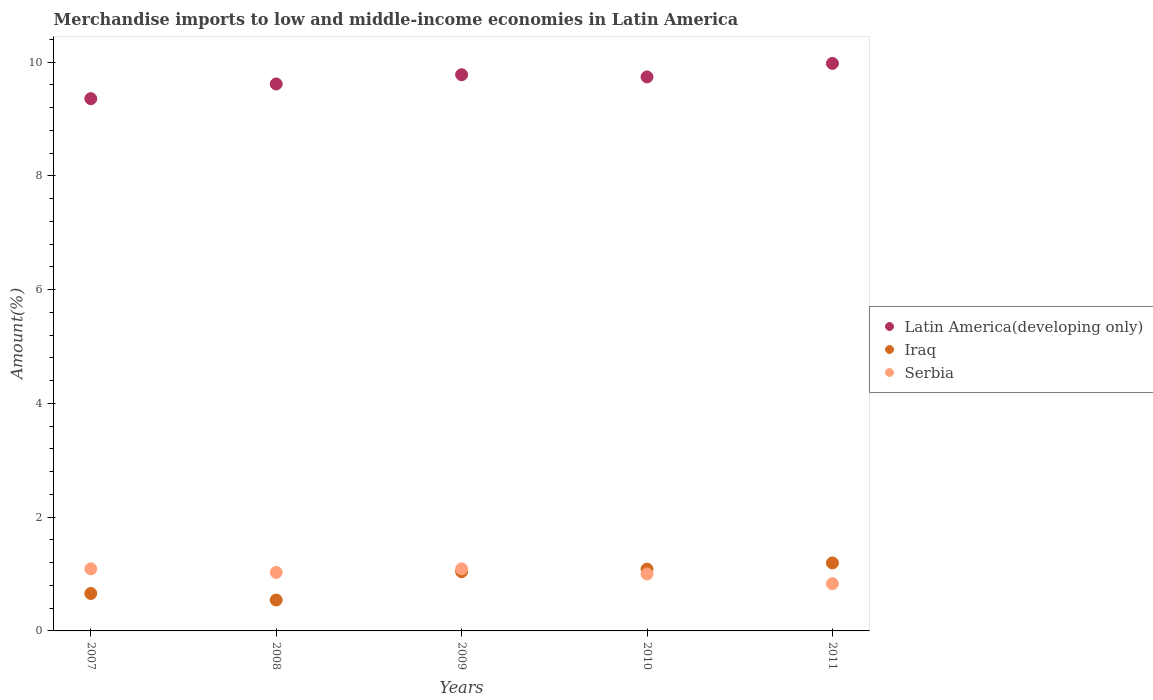How many different coloured dotlines are there?
Provide a succinct answer. 3. Is the number of dotlines equal to the number of legend labels?
Provide a short and direct response. Yes. What is the percentage of amount earned from merchandise imports in Iraq in 2011?
Provide a short and direct response. 1.2. Across all years, what is the maximum percentage of amount earned from merchandise imports in Serbia?
Keep it short and to the point. 1.09. Across all years, what is the minimum percentage of amount earned from merchandise imports in Serbia?
Offer a very short reply. 0.83. What is the total percentage of amount earned from merchandise imports in Iraq in the graph?
Keep it short and to the point. 4.52. What is the difference between the percentage of amount earned from merchandise imports in Serbia in 2007 and that in 2011?
Your answer should be compact. 0.26. What is the difference between the percentage of amount earned from merchandise imports in Latin America(developing only) in 2007 and the percentage of amount earned from merchandise imports in Iraq in 2008?
Give a very brief answer. 8.81. What is the average percentage of amount earned from merchandise imports in Serbia per year?
Keep it short and to the point. 1.01. In the year 2009, what is the difference between the percentage of amount earned from merchandise imports in Latin America(developing only) and percentage of amount earned from merchandise imports in Iraq?
Offer a very short reply. 8.74. What is the ratio of the percentage of amount earned from merchandise imports in Latin America(developing only) in 2008 to that in 2011?
Your response must be concise. 0.96. What is the difference between the highest and the second highest percentage of amount earned from merchandise imports in Latin America(developing only)?
Provide a succinct answer. 0.2. What is the difference between the highest and the lowest percentage of amount earned from merchandise imports in Latin America(developing only)?
Offer a terse response. 0.62. Is the sum of the percentage of amount earned from merchandise imports in Serbia in 2008 and 2009 greater than the maximum percentage of amount earned from merchandise imports in Iraq across all years?
Your answer should be compact. Yes. Does the percentage of amount earned from merchandise imports in Latin America(developing only) monotonically increase over the years?
Make the answer very short. No. Is the percentage of amount earned from merchandise imports in Latin America(developing only) strictly less than the percentage of amount earned from merchandise imports in Serbia over the years?
Your response must be concise. No. Does the graph contain any zero values?
Give a very brief answer. No. How many legend labels are there?
Your answer should be compact. 3. What is the title of the graph?
Your answer should be very brief. Merchandise imports to low and middle-income economies in Latin America. What is the label or title of the X-axis?
Your response must be concise. Years. What is the label or title of the Y-axis?
Your answer should be compact. Amount(%). What is the Amount(%) in Latin America(developing only) in 2007?
Keep it short and to the point. 9.36. What is the Amount(%) of Iraq in 2007?
Provide a short and direct response. 0.66. What is the Amount(%) in Serbia in 2007?
Offer a terse response. 1.09. What is the Amount(%) in Latin America(developing only) in 2008?
Your response must be concise. 9.61. What is the Amount(%) of Iraq in 2008?
Provide a succinct answer. 0.54. What is the Amount(%) in Serbia in 2008?
Provide a short and direct response. 1.03. What is the Amount(%) of Latin America(developing only) in 2009?
Give a very brief answer. 9.78. What is the Amount(%) of Iraq in 2009?
Your answer should be very brief. 1.04. What is the Amount(%) in Serbia in 2009?
Make the answer very short. 1.09. What is the Amount(%) of Latin America(developing only) in 2010?
Provide a short and direct response. 9.74. What is the Amount(%) in Iraq in 2010?
Make the answer very short. 1.09. What is the Amount(%) in Serbia in 2010?
Your answer should be very brief. 1. What is the Amount(%) in Latin America(developing only) in 2011?
Provide a succinct answer. 9.98. What is the Amount(%) in Iraq in 2011?
Your answer should be compact. 1.2. What is the Amount(%) in Serbia in 2011?
Your response must be concise. 0.83. Across all years, what is the maximum Amount(%) of Latin America(developing only)?
Your answer should be very brief. 9.98. Across all years, what is the maximum Amount(%) in Iraq?
Provide a short and direct response. 1.2. Across all years, what is the maximum Amount(%) of Serbia?
Provide a succinct answer. 1.09. Across all years, what is the minimum Amount(%) of Latin America(developing only)?
Offer a very short reply. 9.36. Across all years, what is the minimum Amount(%) in Iraq?
Make the answer very short. 0.54. Across all years, what is the minimum Amount(%) in Serbia?
Provide a succinct answer. 0.83. What is the total Amount(%) in Latin America(developing only) in the graph?
Provide a succinct answer. 48.46. What is the total Amount(%) in Iraq in the graph?
Provide a succinct answer. 4.52. What is the total Amount(%) in Serbia in the graph?
Offer a terse response. 5.04. What is the difference between the Amount(%) in Latin America(developing only) in 2007 and that in 2008?
Make the answer very short. -0.26. What is the difference between the Amount(%) in Iraq in 2007 and that in 2008?
Provide a succinct answer. 0.11. What is the difference between the Amount(%) in Serbia in 2007 and that in 2008?
Make the answer very short. 0.06. What is the difference between the Amount(%) in Latin America(developing only) in 2007 and that in 2009?
Offer a terse response. -0.42. What is the difference between the Amount(%) of Iraq in 2007 and that in 2009?
Your response must be concise. -0.38. What is the difference between the Amount(%) of Serbia in 2007 and that in 2009?
Offer a very short reply. -0. What is the difference between the Amount(%) of Latin America(developing only) in 2007 and that in 2010?
Make the answer very short. -0.38. What is the difference between the Amount(%) in Iraq in 2007 and that in 2010?
Provide a short and direct response. -0.43. What is the difference between the Amount(%) of Serbia in 2007 and that in 2010?
Make the answer very short. 0.09. What is the difference between the Amount(%) in Latin America(developing only) in 2007 and that in 2011?
Keep it short and to the point. -0.62. What is the difference between the Amount(%) of Iraq in 2007 and that in 2011?
Your answer should be compact. -0.54. What is the difference between the Amount(%) in Serbia in 2007 and that in 2011?
Your answer should be very brief. 0.26. What is the difference between the Amount(%) in Latin America(developing only) in 2008 and that in 2009?
Give a very brief answer. -0.16. What is the difference between the Amount(%) of Iraq in 2008 and that in 2009?
Provide a succinct answer. -0.5. What is the difference between the Amount(%) of Serbia in 2008 and that in 2009?
Your response must be concise. -0.06. What is the difference between the Amount(%) of Latin America(developing only) in 2008 and that in 2010?
Your answer should be very brief. -0.12. What is the difference between the Amount(%) in Iraq in 2008 and that in 2010?
Your response must be concise. -0.54. What is the difference between the Amount(%) in Serbia in 2008 and that in 2010?
Make the answer very short. 0.03. What is the difference between the Amount(%) of Latin America(developing only) in 2008 and that in 2011?
Your answer should be very brief. -0.36. What is the difference between the Amount(%) in Iraq in 2008 and that in 2011?
Keep it short and to the point. -0.65. What is the difference between the Amount(%) of Serbia in 2008 and that in 2011?
Your response must be concise. 0.2. What is the difference between the Amount(%) of Latin America(developing only) in 2009 and that in 2010?
Provide a succinct answer. 0.04. What is the difference between the Amount(%) of Iraq in 2009 and that in 2010?
Ensure brevity in your answer.  -0.04. What is the difference between the Amount(%) of Serbia in 2009 and that in 2010?
Offer a terse response. 0.09. What is the difference between the Amount(%) of Latin America(developing only) in 2009 and that in 2011?
Keep it short and to the point. -0.2. What is the difference between the Amount(%) of Iraq in 2009 and that in 2011?
Keep it short and to the point. -0.15. What is the difference between the Amount(%) of Serbia in 2009 and that in 2011?
Your answer should be very brief. 0.26. What is the difference between the Amount(%) in Latin America(developing only) in 2010 and that in 2011?
Keep it short and to the point. -0.24. What is the difference between the Amount(%) of Iraq in 2010 and that in 2011?
Ensure brevity in your answer.  -0.11. What is the difference between the Amount(%) of Serbia in 2010 and that in 2011?
Your answer should be very brief. 0.17. What is the difference between the Amount(%) of Latin America(developing only) in 2007 and the Amount(%) of Iraq in 2008?
Your response must be concise. 8.81. What is the difference between the Amount(%) in Latin America(developing only) in 2007 and the Amount(%) in Serbia in 2008?
Ensure brevity in your answer.  8.33. What is the difference between the Amount(%) in Iraq in 2007 and the Amount(%) in Serbia in 2008?
Provide a short and direct response. -0.37. What is the difference between the Amount(%) in Latin America(developing only) in 2007 and the Amount(%) in Iraq in 2009?
Give a very brief answer. 8.31. What is the difference between the Amount(%) in Latin America(developing only) in 2007 and the Amount(%) in Serbia in 2009?
Your answer should be compact. 8.27. What is the difference between the Amount(%) of Iraq in 2007 and the Amount(%) of Serbia in 2009?
Your answer should be very brief. -0.43. What is the difference between the Amount(%) in Latin America(developing only) in 2007 and the Amount(%) in Iraq in 2010?
Provide a succinct answer. 8.27. What is the difference between the Amount(%) in Latin America(developing only) in 2007 and the Amount(%) in Serbia in 2010?
Keep it short and to the point. 8.36. What is the difference between the Amount(%) of Iraq in 2007 and the Amount(%) of Serbia in 2010?
Offer a terse response. -0.34. What is the difference between the Amount(%) in Latin America(developing only) in 2007 and the Amount(%) in Iraq in 2011?
Offer a very short reply. 8.16. What is the difference between the Amount(%) of Latin America(developing only) in 2007 and the Amount(%) of Serbia in 2011?
Make the answer very short. 8.53. What is the difference between the Amount(%) in Iraq in 2007 and the Amount(%) in Serbia in 2011?
Your answer should be very brief. -0.17. What is the difference between the Amount(%) in Latin America(developing only) in 2008 and the Amount(%) in Iraq in 2009?
Make the answer very short. 8.57. What is the difference between the Amount(%) of Latin America(developing only) in 2008 and the Amount(%) of Serbia in 2009?
Ensure brevity in your answer.  8.52. What is the difference between the Amount(%) in Iraq in 2008 and the Amount(%) in Serbia in 2009?
Your answer should be compact. -0.55. What is the difference between the Amount(%) of Latin America(developing only) in 2008 and the Amount(%) of Iraq in 2010?
Ensure brevity in your answer.  8.53. What is the difference between the Amount(%) of Latin America(developing only) in 2008 and the Amount(%) of Serbia in 2010?
Offer a terse response. 8.61. What is the difference between the Amount(%) of Iraq in 2008 and the Amount(%) of Serbia in 2010?
Give a very brief answer. -0.46. What is the difference between the Amount(%) in Latin America(developing only) in 2008 and the Amount(%) in Iraq in 2011?
Offer a very short reply. 8.42. What is the difference between the Amount(%) of Latin America(developing only) in 2008 and the Amount(%) of Serbia in 2011?
Provide a short and direct response. 8.78. What is the difference between the Amount(%) of Iraq in 2008 and the Amount(%) of Serbia in 2011?
Your answer should be compact. -0.29. What is the difference between the Amount(%) in Latin America(developing only) in 2009 and the Amount(%) in Iraq in 2010?
Keep it short and to the point. 8.69. What is the difference between the Amount(%) of Latin America(developing only) in 2009 and the Amount(%) of Serbia in 2010?
Your response must be concise. 8.78. What is the difference between the Amount(%) of Iraq in 2009 and the Amount(%) of Serbia in 2010?
Provide a short and direct response. 0.04. What is the difference between the Amount(%) of Latin America(developing only) in 2009 and the Amount(%) of Iraq in 2011?
Keep it short and to the point. 8.58. What is the difference between the Amount(%) of Latin America(developing only) in 2009 and the Amount(%) of Serbia in 2011?
Offer a very short reply. 8.95. What is the difference between the Amount(%) of Iraq in 2009 and the Amount(%) of Serbia in 2011?
Offer a very short reply. 0.21. What is the difference between the Amount(%) of Latin America(developing only) in 2010 and the Amount(%) of Iraq in 2011?
Make the answer very short. 8.54. What is the difference between the Amount(%) in Latin America(developing only) in 2010 and the Amount(%) in Serbia in 2011?
Ensure brevity in your answer.  8.91. What is the difference between the Amount(%) of Iraq in 2010 and the Amount(%) of Serbia in 2011?
Your response must be concise. 0.26. What is the average Amount(%) in Latin America(developing only) per year?
Keep it short and to the point. 9.69. What is the average Amount(%) of Iraq per year?
Your answer should be compact. 0.9. What is the average Amount(%) in Serbia per year?
Your answer should be very brief. 1.01. In the year 2007, what is the difference between the Amount(%) in Latin America(developing only) and Amount(%) in Iraq?
Make the answer very short. 8.7. In the year 2007, what is the difference between the Amount(%) of Latin America(developing only) and Amount(%) of Serbia?
Your answer should be very brief. 8.27. In the year 2007, what is the difference between the Amount(%) of Iraq and Amount(%) of Serbia?
Keep it short and to the point. -0.43. In the year 2008, what is the difference between the Amount(%) in Latin America(developing only) and Amount(%) in Iraq?
Ensure brevity in your answer.  9.07. In the year 2008, what is the difference between the Amount(%) in Latin America(developing only) and Amount(%) in Serbia?
Make the answer very short. 8.59. In the year 2008, what is the difference between the Amount(%) of Iraq and Amount(%) of Serbia?
Give a very brief answer. -0.48. In the year 2009, what is the difference between the Amount(%) of Latin America(developing only) and Amount(%) of Iraq?
Make the answer very short. 8.74. In the year 2009, what is the difference between the Amount(%) in Latin America(developing only) and Amount(%) in Serbia?
Give a very brief answer. 8.69. In the year 2009, what is the difference between the Amount(%) in Iraq and Amount(%) in Serbia?
Your response must be concise. -0.05. In the year 2010, what is the difference between the Amount(%) in Latin America(developing only) and Amount(%) in Iraq?
Provide a short and direct response. 8.65. In the year 2010, what is the difference between the Amount(%) of Latin America(developing only) and Amount(%) of Serbia?
Your answer should be very brief. 8.74. In the year 2010, what is the difference between the Amount(%) of Iraq and Amount(%) of Serbia?
Your answer should be compact. 0.09. In the year 2011, what is the difference between the Amount(%) of Latin America(developing only) and Amount(%) of Iraq?
Your response must be concise. 8.78. In the year 2011, what is the difference between the Amount(%) of Latin America(developing only) and Amount(%) of Serbia?
Keep it short and to the point. 9.15. In the year 2011, what is the difference between the Amount(%) of Iraq and Amount(%) of Serbia?
Provide a short and direct response. 0.36. What is the ratio of the Amount(%) of Latin America(developing only) in 2007 to that in 2008?
Give a very brief answer. 0.97. What is the ratio of the Amount(%) of Iraq in 2007 to that in 2008?
Ensure brevity in your answer.  1.21. What is the ratio of the Amount(%) in Serbia in 2007 to that in 2008?
Make the answer very short. 1.06. What is the ratio of the Amount(%) in Latin America(developing only) in 2007 to that in 2009?
Provide a short and direct response. 0.96. What is the ratio of the Amount(%) of Iraq in 2007 to that in 2009?
Your response must be concise. 0.63. What is the ratio of the Amount(%) of Latin America(developing only) in 2007 to that in 2010?
Provide a succinct answer. 0.96. What is the ratio of the Amount(%) of Iraq in 2007 to that in 2010?
Keep it short and to the point. 0.61. What is the ratio of the Amount(%) in Serbia in 2007 to that in 2010?
Give a very brief answer. 1.09. What is the ratio of the Amount(%) in Latin America(developing only) in 2007 to that in 2011?
Your response must be concise. 0.94. What is the ratio of the Amount(%) of Iraq in 2007 to that in 2011?
Offer a terse response. 0.55. What is the ratio of the Amount(%) in Serbia in 2007 to that in 2011?
Keep it short and to the point. 1.31. What is the ratio of the Amount(%) of Latin America(developing only) in 2008 to that in 2009?
Provide a succinct answer. 0.98. What is the ratio of the Amount(%) in Iraq in 2008 to that in 2009?
Offer a terse response. 0.52. What is the ratio of the Amount(%) in Serbia in 2008 to that in 2009?
Your answer should be very brief. 0.94. What is the ratio of the Amount(%) of Latin America(developing only) in 2008 to that in 2010?
Keep it short and to the point. 0.99. What is the ratio of the Amount(%) in Iraq in 2008 to that in 2010?
Ensure brevity in your answer.  0.5. What is the ratio of the Amount(%) in Serbia in 2008 to that in 2010?
Provide a short and direct response. 1.03. What is the ratio of the Amount(%) in Latin America(developing only) in 2008 to that in 2011?
Offer a terse response. 0.96. What is the ratio of the Amount(%) in Iraq in 2008 to that in 2011?
Provide a succinct answer. 0.45. What is the ratio of the Amount(%) in Serbia in 2008 to that in 2011?
Offer a terse response. 1.24. What is the ratio of the Amount(%) of Latin America(developing only) in 2009 to that in 2010?
Your response must be concise. 1. What is the ratio of the Amount(%) of Iraq in 2009 to that in 2010?
Your answer should be very brief. 0.96. What is the ratio of the Amount(%) in Serbia in 2009 to that in 2010?
Keep it short and to the point. 1.09. What is the ratio of the Amount(%) in Latin America(developing only) in 2009 to that in 2011?
Offer a very short reply. 0.98. What is the ratio of the Amount(%) of Iraq in 2009 to that in 2011?
Offer a very short reply. 0.87. What is the ratio of the Amount(%) in Serbia in 2009 to that in 2011?
Your answer should be very brief. 1.31. What is the ratio of the Amount(%) of Latin America(developing only) in 2010 to that in 2011?
Ensure brevity in your answer.  0.98. What is the ratio of the Amount(%) in Serbia in 2010 to that in 2011?
Offer a very short reply. 1.21. What is the difference between the highest and the second highest Amount(%) of Latin America(developing only)?
Offer a terse response. 0.2. What is the difference between the highest and the second highest Amount(%) of Iraq?
Make the answer very short. 0.11. What is the difference between the highest and the lowest Amount(%) in Latin America(developing only)?
Provide a short and direct response. 0.62. What is the difference between the highest and the lowest Amount(%) in Iraq?
Make the answer very short. 0.65. What is the difference between the highest and the lowest Amount(%) of Serbia?
Offer a very short reply. 0.26. 